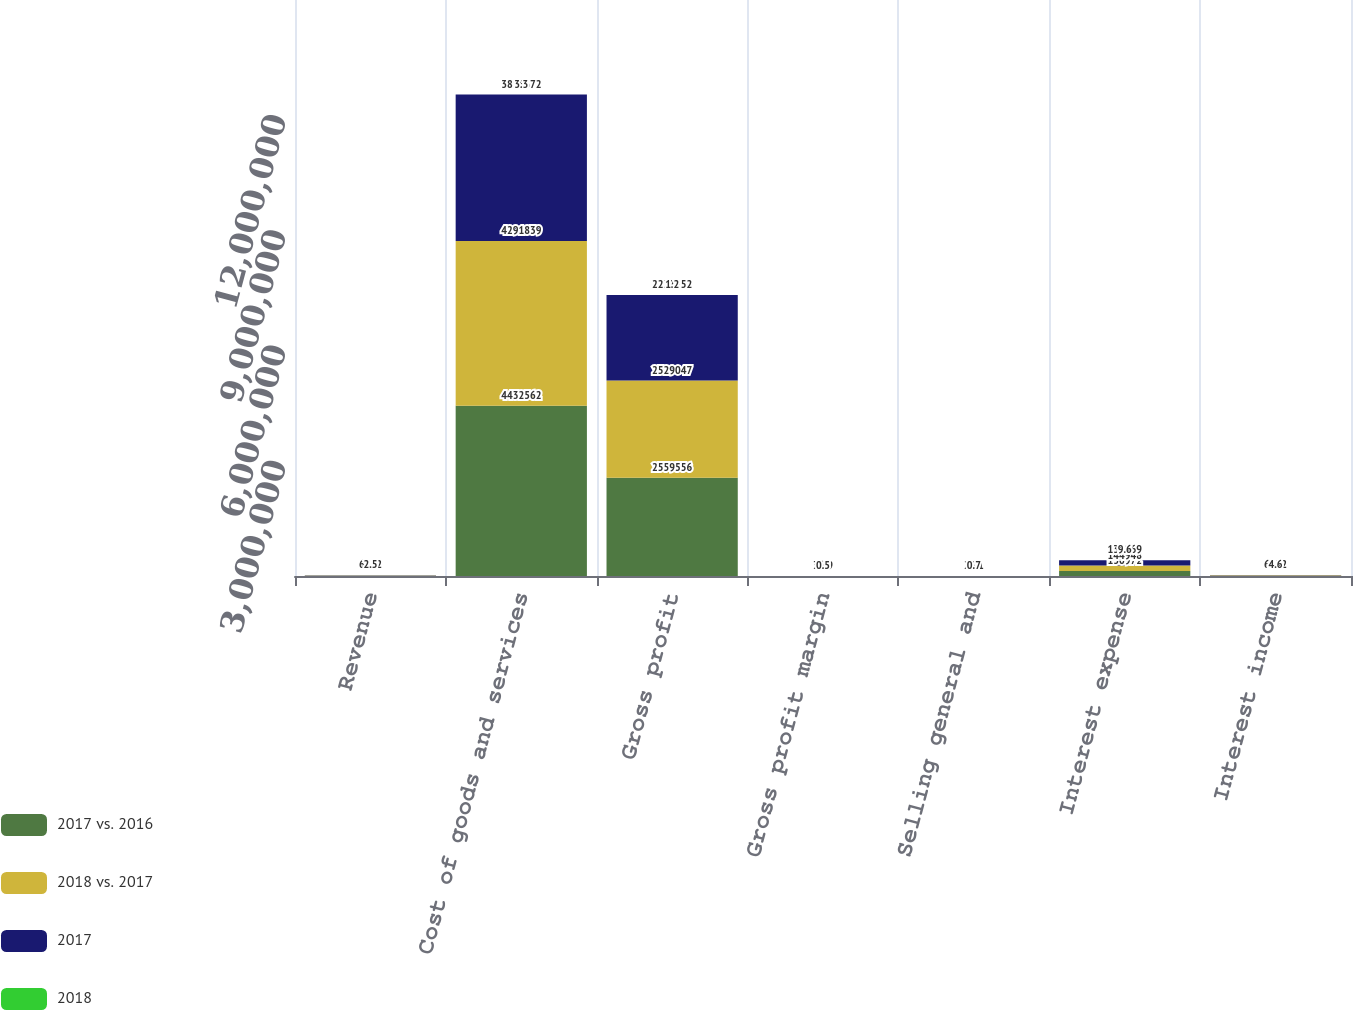Convert chart to OTSL. <chart><loc_0><loc_0><loc_500><loc_500><stacked_bar_chart><ecel><fcel>Revenue<fcel>Cost of goods and services<fcel>Gross profit<fcel>Gross profit margin<fcel>Selling general and<fcel>Interest expense<fcel>Interest income<nl><fcel>2017 vs. 2016<fcel>6752<fcel>4.43256e+06<fcel>2.55956e+06<fcel>36.6<fcel>24.5<fcel>130972<fcel>8881<nl><fcel>2018 vs. 2017<fcel>6752<fcel>4.29184e+06<fcel>2.52905e+06<fcel>37.1<fcel>25.2<fcel>144948<fcel>8491<nl><fcel>2017<fcel>6752<fcel>3.81567e+06<fcel>2.22755e+06<fcel>36.9<fcel>25.1<fcel>135969<fcel>6752<nl><fcel>2018<fcel>2.5<fcel>3.3<fcel>1.2<fcel>0.5<fcel>0.7<fcel>9.6<fcel>4.6<nl></chart> 